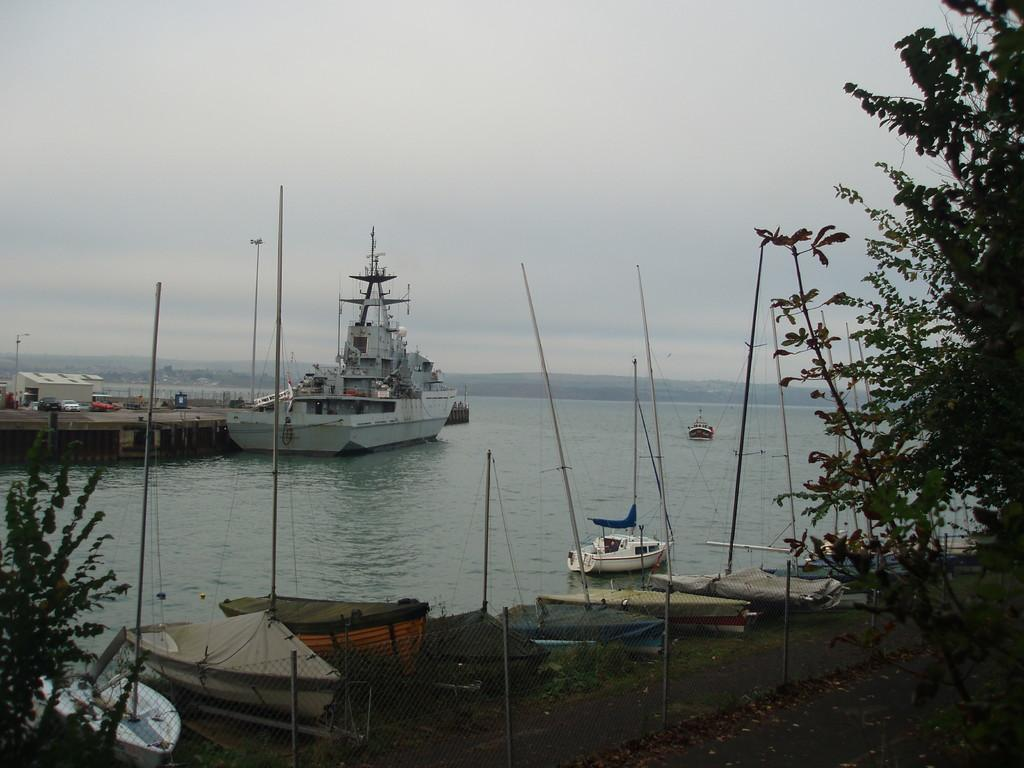What types of watercraft are present in the image? There are ships and boats on the water in the image. Are there any boats on land? Yes, there are other boats on the ground in the image. What other natural elements can be seen in the image? Trees, mountains, and the sky are visible in the image. What man-made structures are present in the image? There are houses and poles in the image. What type of book is being read by the ducks in the image? There are no ducks or books present in the image. Can you describe the frog's interaction with the ships in the image? There are no frogs present in the image, so it is not possible to describe any interaction with the ships. 